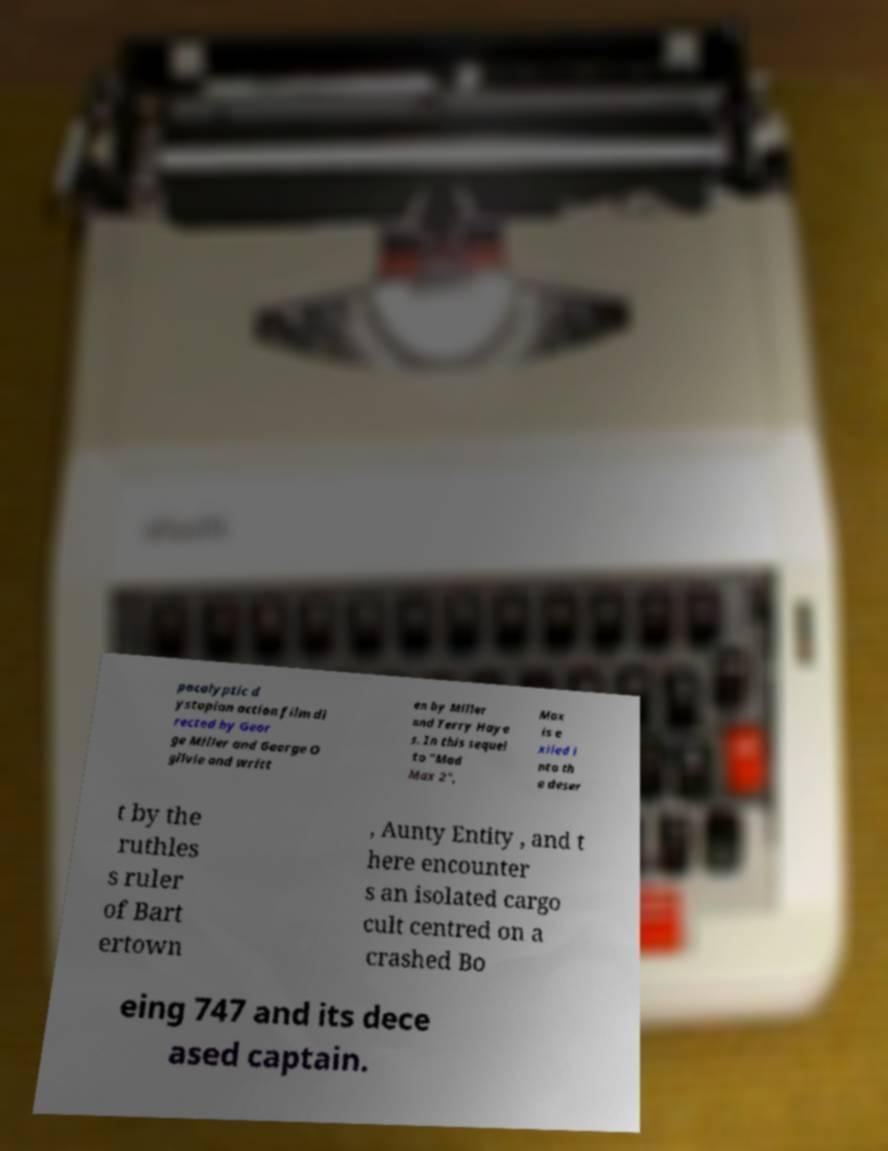Please read and relay the text visible in this image. What does it say? pocalyptic d ystopian action film di rected by Geor ge Miller and George O gilvie and writt en by Miller and Terry Haye s. In this sequel to "Mad Max 2", Max is e xiled i nto th e deser t by the ruthles s ruler of Bart ertown , Aunty Entity , and t here encounter s an isolated cargo cult centred on a crashed Bo eing 747 and its dece ased captain. 